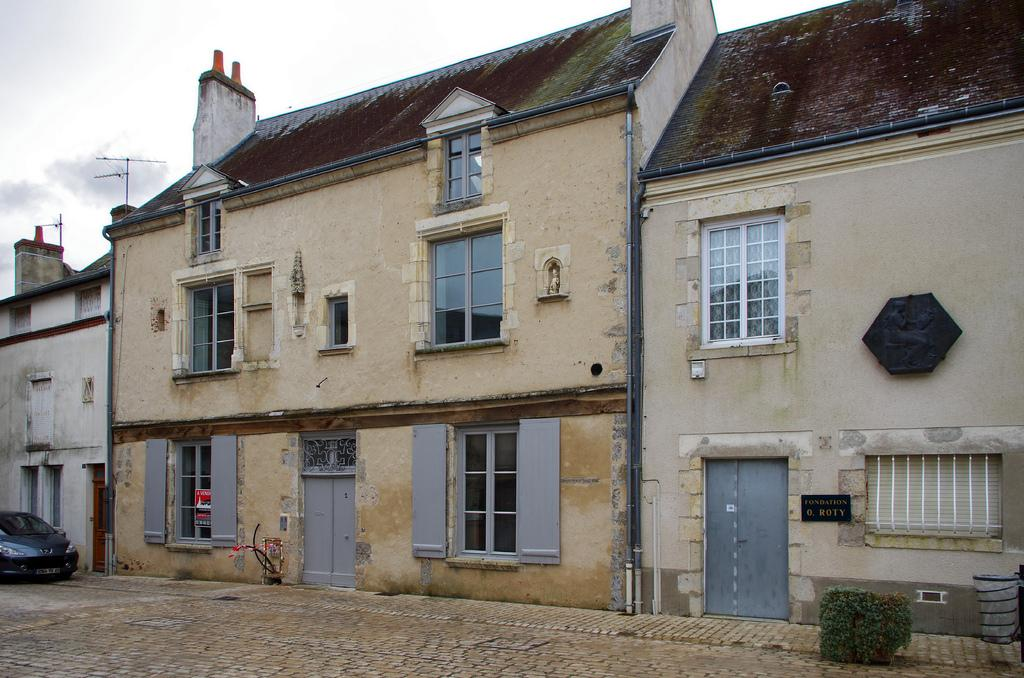What type of structures can be seen in the image? There are buildings in the image. What mode of transportation is visible in the image? There is a car in the image. What type of vegetation is present in the image? There is a plant in the image. How would you describe the weather based on the image? The sky is cloudy in the image, suggesting a potentially overcast or cloudy day. What type of leather is used to make the locket in the image? There is no locket present in the image, so it is not possible to determine the type of leather used. How does the plant in the image express its emotions? Plants do not have emotions or the ability to express them, so this question cannot be answered. 